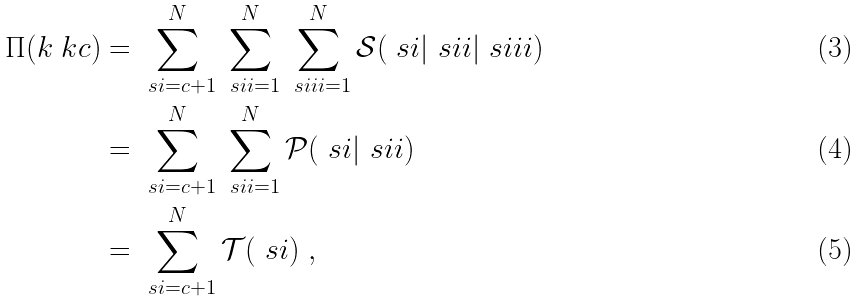<formula> <loc_0><loc_0><loc_500><loc_500>\Pi ( k _ { \ } k c ) & = \sum _ { \ s i = c + 1 } ^ { N } \sum _ { \ s i i = 1 } ^ { N } \sum _ { \ s i i i = 1 } ^ { N } \mathcal { S } ( \ s i | \ s i i | \ s i i i ) \\ & = \sum _ { \ s i = c + 1 } ^ { N } \sum _ { \ s i i = 1 } ^ { N } \mathcal { P } ( \ s i | \ s i i ) \\ & = \sum _ { \ s i = c + 1 } ^ { N } \mathcal { T } ( \ s i ) \ ,</formula> 